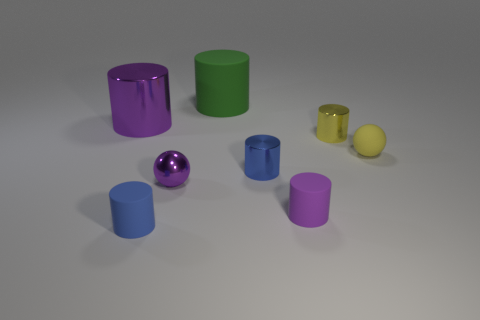How many small blue objects are on the right side of the blue matte object? Upon examining the image carefully, there's one small blue object positioned to the right of the larger blue matte cylinder. 